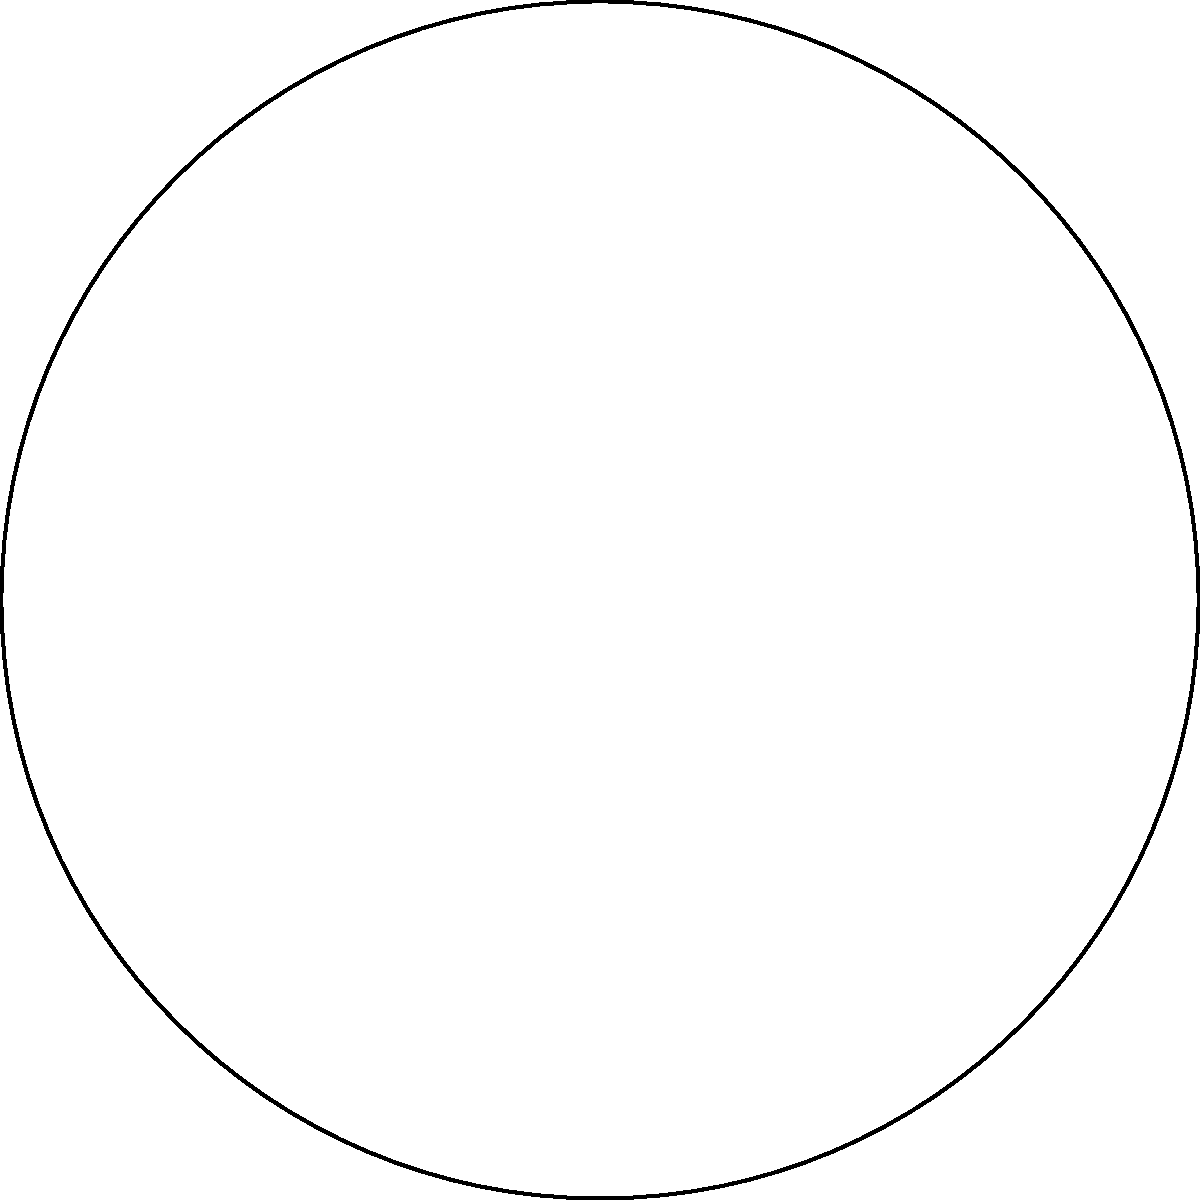A traditional Tulum dreamcatcher has a hexagonal shape with intricate patterns inside, as shown in the diagram. If we consider the rotational symmetry of this dreamcatcher, how many distinct rotations (including the identity rotation) form a group under composition? To determine the number of distinct rotations that form a group under composition for this dreamcatcher, we need to follow these steps:

1) First, we need to identify the order of rotational symmetry. The dreamcatcher has a hexagonal shape, which means it has 6-fold rotational symmetry.

2) The possible rotations are:
   - Identity rotation (0°)
   - Rotation by 60°
   - Rotation by 120°
   - Rotation by 180°
   - Rotation by 240°
   - Rotation by 300°

3) Each of these rotations, when applied, will map the dreamcatcher onto itself.

4) These rotations form a cyclic group of order 6, denoted as $C_6$ or $Z_6$.

5) The group properties are satisfied:
   - Closure: Composing any two rotations results in another rotation in the set.
   - Associativity: Rotation compositions are associative.
   - Identity: The 0° rotation serves as the identity element.
   - Inverse: Each rotation has an inverse (e.g., 60° and 300° are inverses).

Therefore, there are 6 distinct rotations (including the identity rotation) that form a group under composition for this Tulum dreamcatcher.
Answer: 6 